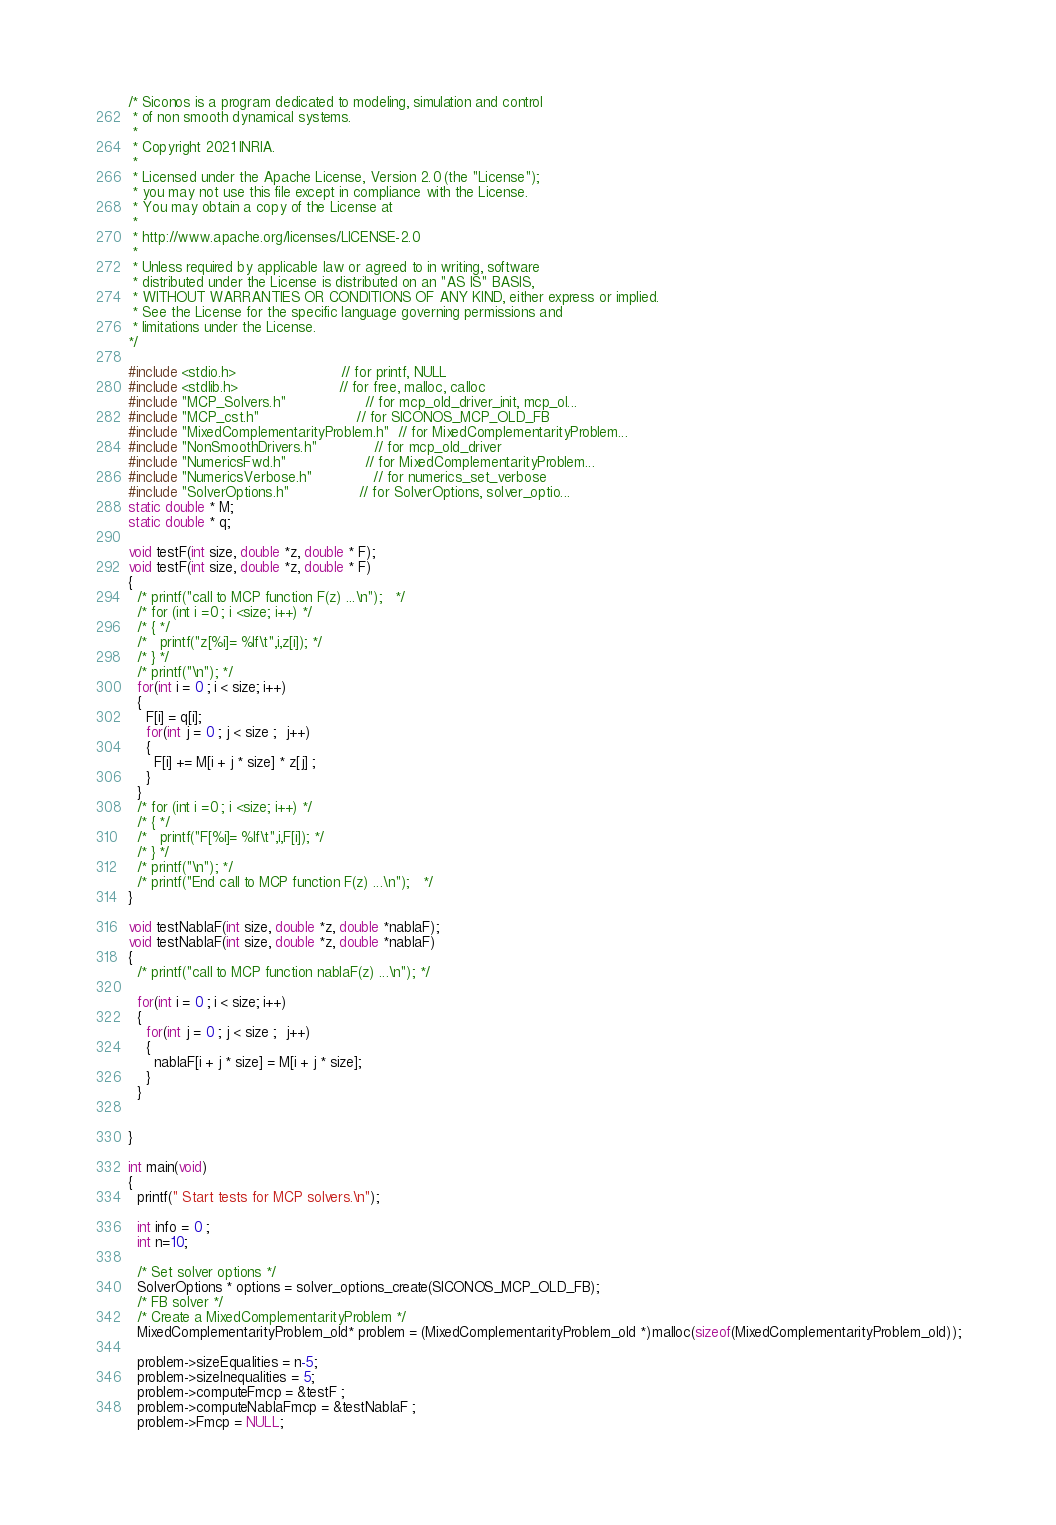Convert code to text. <code><loc_0><loc_0><loc_500><loc_500><_C_>/* Siconos is a program dedicated to modeling, simulation and control
 * of non smooth dynamical systems.
 *
 * Copyright 2021 INRIA.
 *
 * Licensed under the Apache License, Version 2.0 (the "License");
 * you may not use this file except in compliance with the License.
 * You may obtain a copy of the License at
 *
 * http://www.apache.org/licenses/LICENSE-2.0
 *
 * Unless required by applicable law or agreed to in writing, software
 * distributed under the License is distributed on an "AS IS" BASIS,
 * WITHOUT WARRANTIES OR CONDITIONS OF ANY KIND, either express or implied.
 * See the License for the specific language governing permissions and
 * limitations under the License.
*/

#include <stdio.h>                        // for printf, NULL
#include <stdlib.h>                       // for free, malloc, calloc
#include "MCP_Solvers.h"                  // for mcp_old_driver_init, mcp_ol...
#include "MCP_cst.h"                      // for SICONOS_MCP_OLD_FB
#include "MixedComplementarityProblem.h"  // for MixedComplementarityProblem...
#include "NonSmoothDrivers.h"             // for mcp_old_driver
#include "NumericsFwd.h"                  // for MixedComplementarityProblem...
#include "NumericsVerbose.h"              // for numerics_set_verbose
#include "SolverOptions.h"                // for SolverOptions, solver_optio...
static double * M;
static double * q;

void testF(int size, double *z, double * F);
void testF(int size, double *z, double * F)
{
  /* printf("call to MCP function F(z) ...\n");   */
  /* for (int i =0 ; i <size; i++) */
  /* { */
  /*   printf("z[%i]= %lf\t",i,z[i]); */
  /* } */
  /* printf("\n"); */
  for(int i = 0 ; i < size; i++)
  {
    F[i] = q[i];
    for(int j = 0 ; j < size ;  j++)
    {
      F[i] += M[i + j * size] * z[j] ;
    }
  }
  /* for (int i =0 ; i <size; i++) */
  /* { */
  /*   printf("F[%i]= %lf\t",i,F[i]); */
  /* } */
  /* printf("\n"); */
  /* printf("End call to MCP function F(z) ...\n");   */
}

void testNablaF(int size, double *z, double *nablaF);
void testNablaF(int size, double *z, double *nablaF)
{
  /* printf("call to MCP function nablaF(z) ...\n"); */

  for(int i = 0 ; i < size; i++)
  {
    for(int j = 0 ; j < size ;  j++)
    {
      nablaF[i + j * size] = M[i + j * size];
    }
  }


}

int main(void)
{
  printf(" Start tests for MCP solvers.\n");

  int info = 0 ;
  int n=10;

  /* Set solver options */
  SolverOptions * options = solver_options_create(SICONOS_MCP_OLD_FB);
  /* FB solver */
  /* Create a MixedComplementarityProblem */
  MixedComplementarityProblem_old* problem = (MixedComplementarityProblem_old *)malloc(sizeof(MixedComplementarityProblem_old));

  problem->sizeEqualities = n-5;
  problem->sizeInequalities = 5;
  problem->computeFmcp = &testF ;
  problem->computeNablaFmcp = &testNablaF ;
  problem->Fmcp = NULL;</code> 